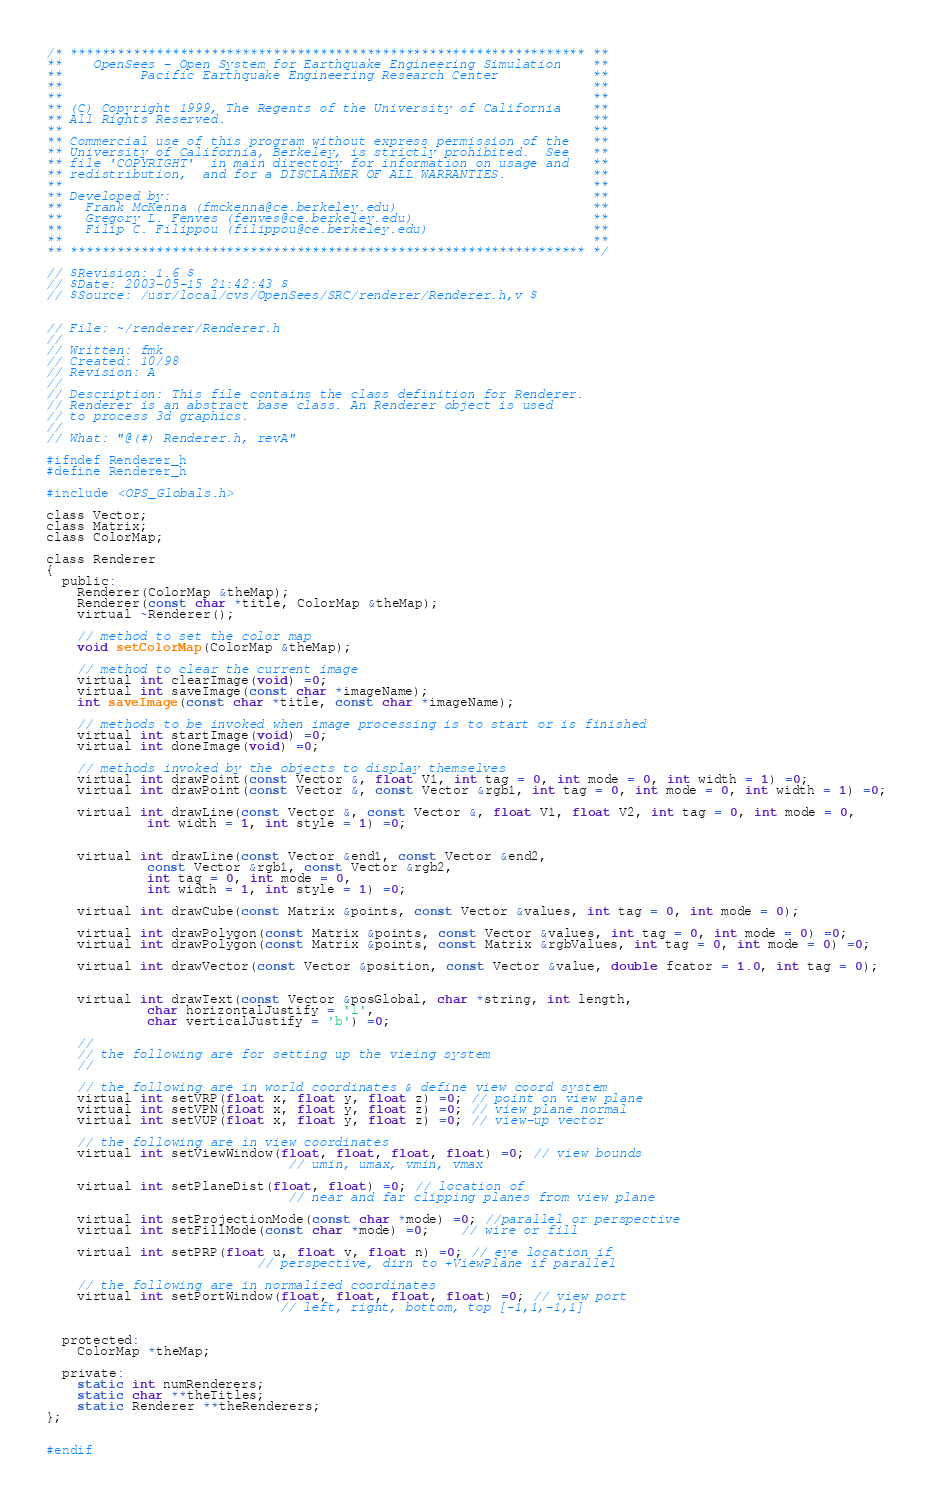<code> <loc_0><loc_0><loc_500><loc_500><_C_>/* ****************************************************************** **
**    OpenSees - Open System for Earthquake Engineering Simulation    **
**          Pacific Earthquake Engineering Research Center            **
**                                                                    **
**                                                                    **
** (C) Copyright 1999, The Regents of the University of California    **
** All Rights Reserved.                                               **
**                                                                    **
** Commercial use of this program without express permission of the   **
** University of California, Berkeley, is strictly prohibited.  See   **
** file 'COPYRIGHT'  in main directory for information on usage and   **
** redistribution,  and for a DISCLAIMER OF ALL WARRANTIES.           **
**                                                                    **
** Developed by:                                                      **
**   Frank McKenna (fmckenna@ce.berkeley.edu)                         **
**   Gregory L. Fenves (fenves@ce.berkeley.edu)                       **
**   Filip C. Filippou (filippou@ce.berkeley.edu)                     **
**                                                                    **
** ****************************************************************** */
                                                                        
// $Revision: 1.6 $
// $Date: 2003-05-15 21:42:43 $
// $Source: /usr/local/cvs/OpenSees/SRC/renderer/Renderer.h,v $
                                                                        
                                                                        
// File: ~/renderer/Renderer.h
//
// Written: fmk 
// Created: 10/98
// Revision: A
//
// Description: This file contains the class definition for Renderer.
// Renderer is an abstract base class. An Renderer object is used
// to process 3d graphics.
//
// What: "@(#) Renderer.h, revA"

#ifndef Renderer_h
#define Renderer_h

#include <OPS_Globals.h>

class Vector;
class Matrix;
class ColorMap;

class Renderer
{
  public:
    Renderer(ColorMap &theMap);    
    Renderer(const char *title, ColorMap &theMap);    
    virtual ~Renderer();

    // method to set the color map
    void setColorMap(ColorMap &theMap);

    // method to clear the current image
    virtual int clearImage(void) =0;    
    virtual int saveImage(const char *imageName);
    int saveImage(const char *title, const char *imageName);

    // methods to be invoked when image processing is to start or is finished
    virtual int startImage(void) =0;    
    virtual int doneImage(void) =0;

    // methods invoked by the objects to display themselves    
    virtual int drawPoint(const Vector &, float V1, int tag = 0, int mode = 0, int width = 1) =0;
    virtual int drawPoint(const Vector &, const Vector &rgb1, int tag = 0, int mode = 0, int width = 1) =0;

    virtual int drawLine(const Vector &, const Vector &, float V1, float V2, int tag = 0, int mode = 0,
			 int width = 1, int style = 1) =0;
			 
    
    virtual int drawLine(const Vector &end1, const Vector &end2, 
			 const Vector &rgb1, const Vector &rgb2,
			 int tag = 0, int mode = 0,
			 int width = 1, int style = 1) =0;
    
    virtual int drawCube(const Matrix &points, const Vector &values, int tag = 0, int mode = 0);

    virtual int drawPolygon(const Matrix &points, const Vector &values, int tag = 0, int mode = 0) =0;
    virtual int drawPolygon(const Matrix &points, const Matrix &rgbValues, int tag = 0, int mode = 0) =0;

    virtual int drawVector(const Vector &position, const Vector &value, double fcator = 1.0, int tag = 0);

    
    virtual int drawText(const Vector &posGlobal, char *string, int length, 
			 char horizontalJustify = 'l', 
			 char verticalJustify = 'b') =0;    

    // 
    // the following are for setting up the vieing system
    //

    // the following are in world coordinates & define view coord system
    virtual int setVRP(float x, float y, float z) =0; // point on view plane    
    virtual int setVPN(float x, float y, float z) =0; // view plane normal
    virtual int setVUP(float x, float y, float z) =0; // view-up vector
	
    // the following are in view coordinates	
    virtual int setViewWindow(float, float, float, float) =0; // view bounds
                               // umin, umax, vmin, vmax

    virtual int setPlaneDist(float, float) =0; // location of
                               // near and far clipping planes from view plane

    virtual int setProjectionMode(const char *mode) =0; //parallel or perspective
    virtual int setFillMode(const char *mode) =0;    // wire or fill
    
    virtual int setPRP(float u, float v, float n) =0; // eye location if 
	                       // perspective, dirn to +ViewPlane if parallel

    // the following are in normalized coordinates
    virtual int setPortWindow(float, float, float, float) =0; // view port
                              // left, right, bottom, top [-1,1,-1,1]


  protected:
    ColorMap *theMap;
    
  private:
    static int numRenderers;
    static char **theTitles;
    static Renderer **theRenderers;
};


#endif

</code> 